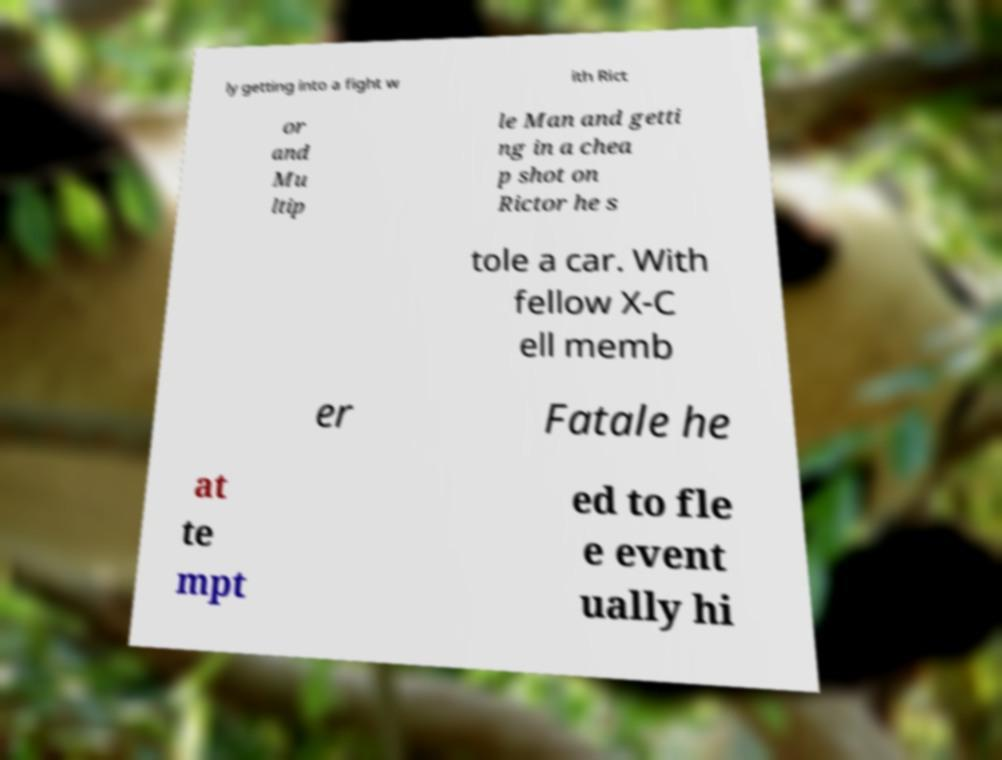Please identify and transcribe the text found in this image. ly getting into a fight w ith Rict or and Mu ltip le Man and getti ng in a chea p shot on Rictor he s tole a car. With fellow X-C ell memb er Fatale he at te mpt ed to fle e event ually hi 